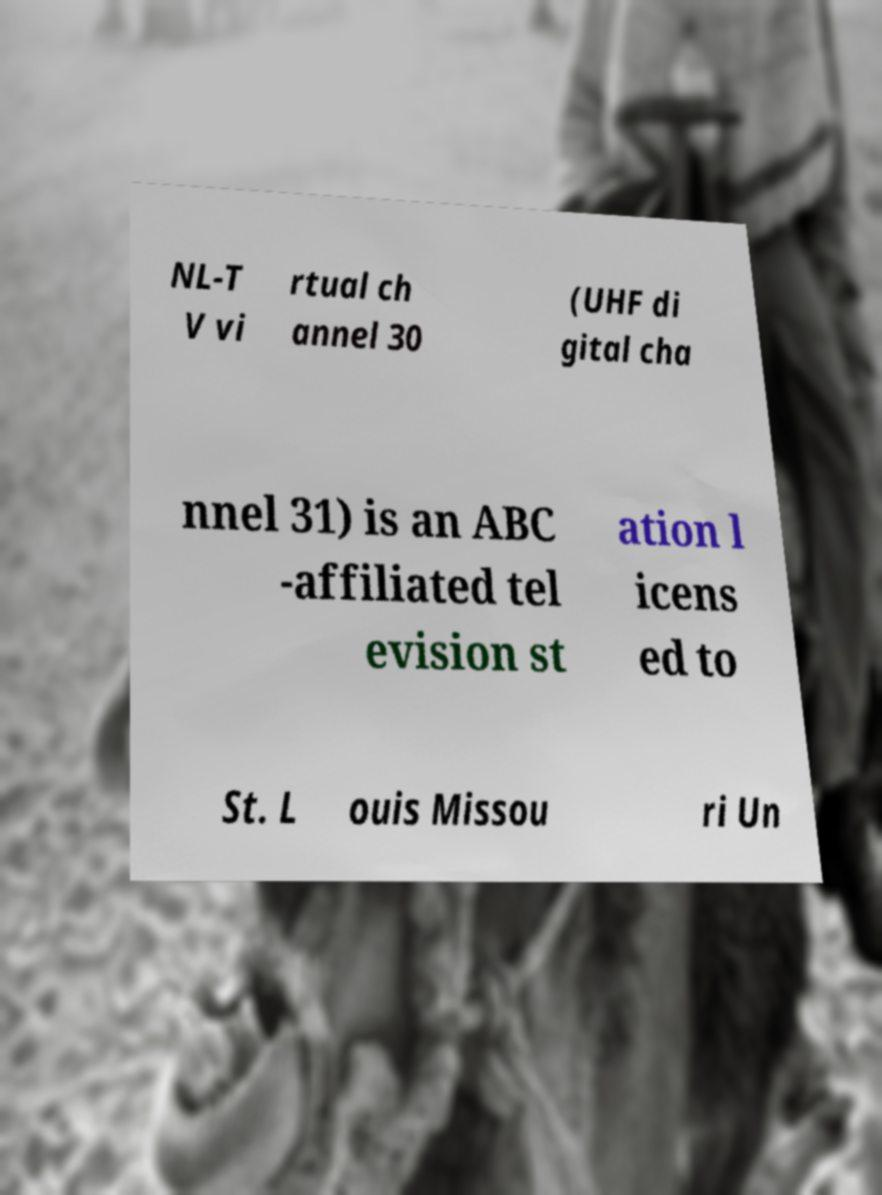Could you assist in decoding the text presented in this image and type it out clearly? NL-T V vi rtual ch annel 30 (UHF di gital cha nnel 31) is an ABC -affiliated tel evision st ation l icens ed to St. L ouis Missou ri Un 